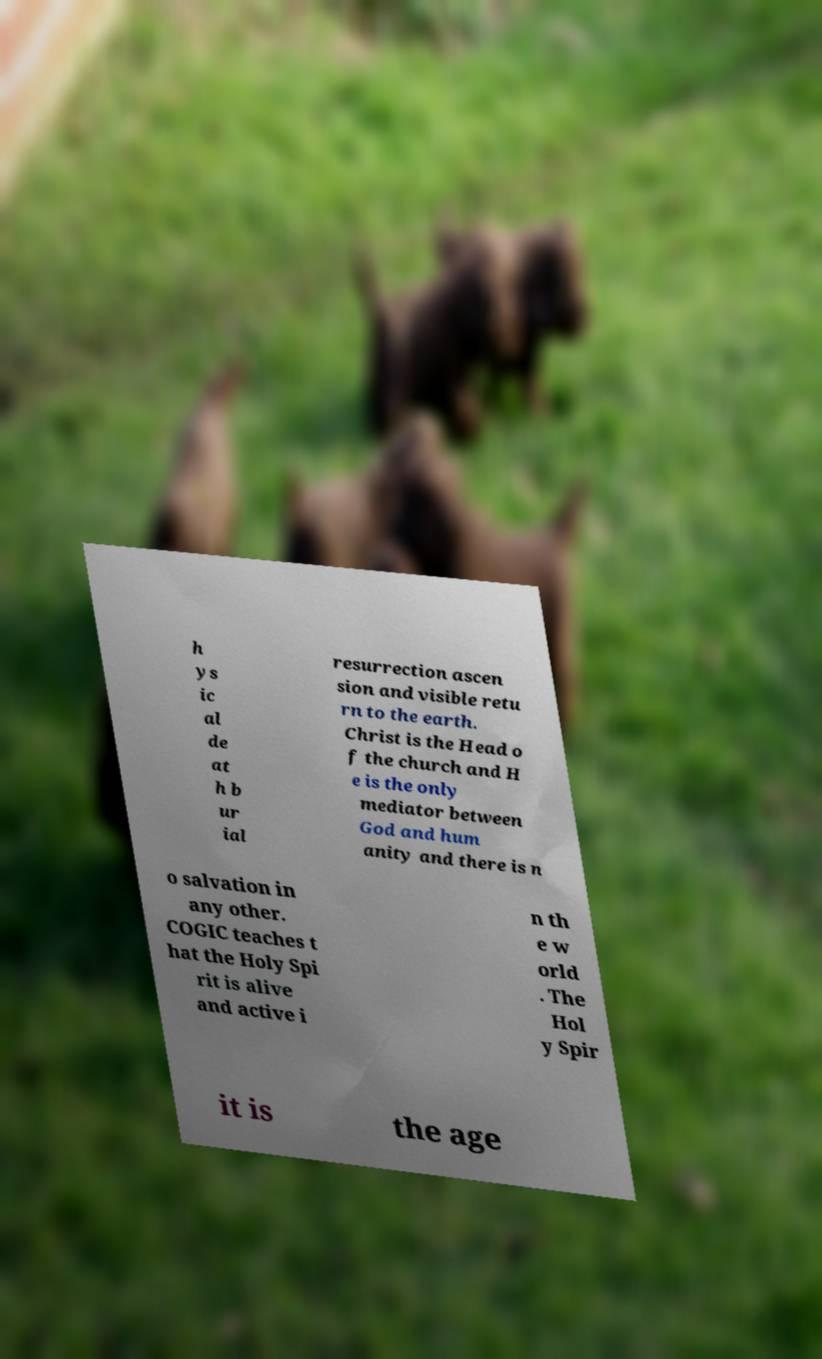Could you extract and type out the text from this image? h ys ic al de at h b ur ial resurrection ascen sion and visible retu rn to the earth. Christ is the Head o f the church and H e is the only mediator between God and hum anity and there is n o salvation in any other. COGIC teaches t hat the Holy Spi rit is alive and active i n th e w orld . The Hol y Spir it is the age 